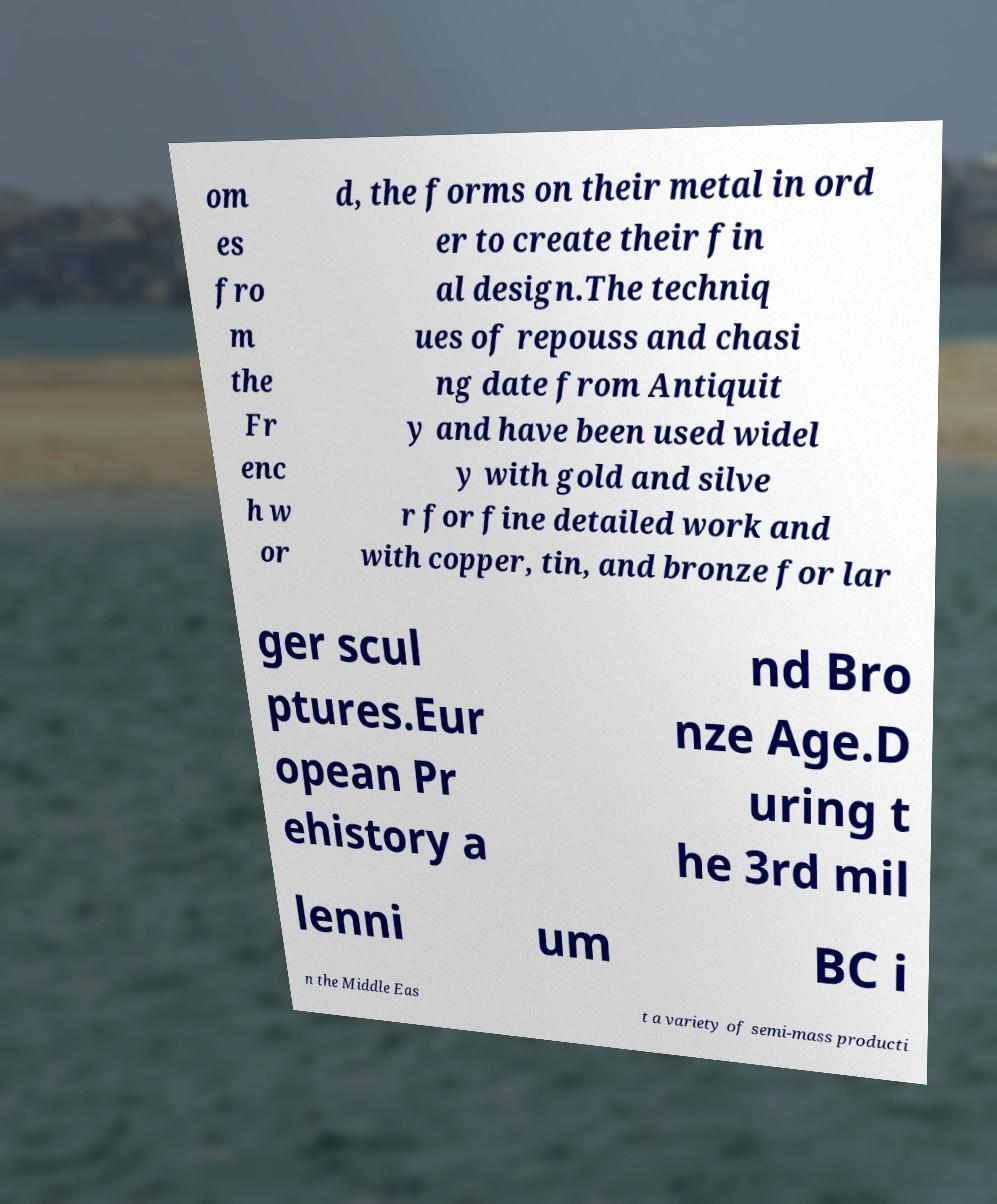Could you assist in decoding the text presented in this image and type it out clearly? om es fro m the Fr enc h w or d, the forms on their metal in ord er to create their fin al design.The techniq ues of repouss and chasi ng date from Antiquit y and have been used widel y with gold and silve r for fine detailed work and with copper, tin, and bronze for lar ger scul ptures.Eur opean Pr ehistory a nd Bro nze Age.D uring t he 3rd mil lenni um BC i n the Middle Eas t a variety of semi-mass producti 